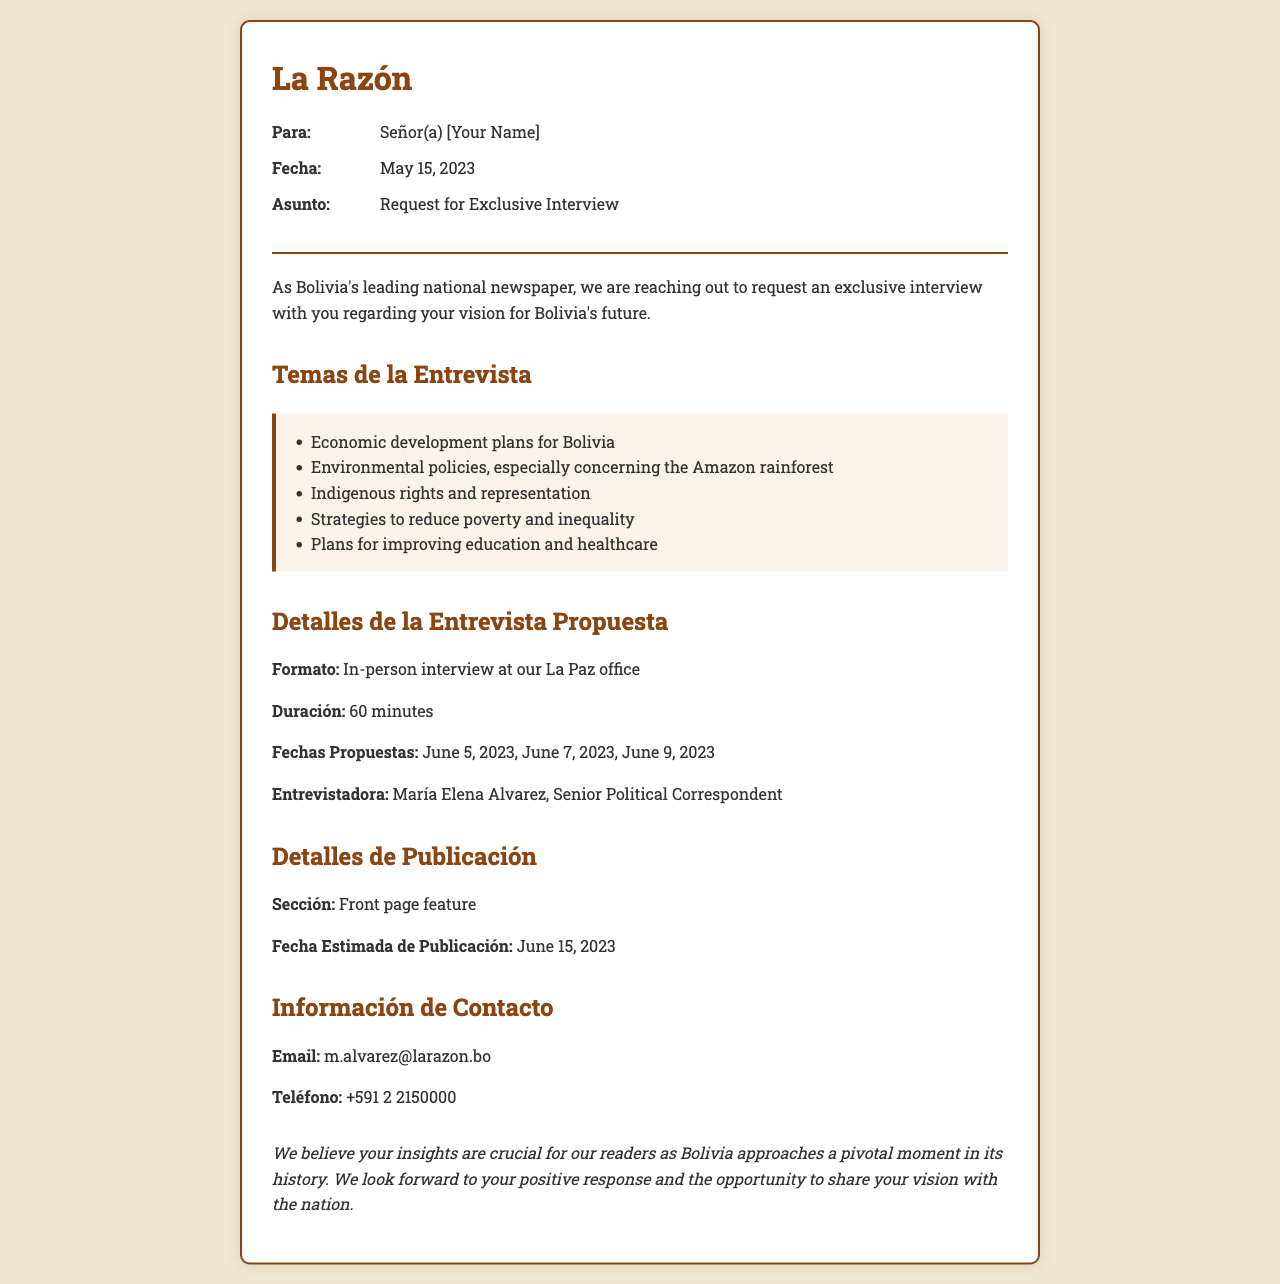what is the date of the fax? The date of the fax is indicated in the document, which is May 15, 2023.
Answer: May 15, 2023 who is the interviewer for the proposed interview? The document states that the interviewer is María Elena Alvarez, Senior Political Correspondent.
Answer: María Elena Alvarez what are the proposed interview dates? The proposed dates for the interview are listed in the document as June 5, 2023, June 7, 2023, and June 9, 2023.
Answer: June 5, 2023, June 7, 2023, June 9, 2023 what is the primary subject of the interview request? The primary subject of the interview request is indicated to be your vision for Bolivia's future.
Answer: Your vision for Bolivia's future how long is the proposed interview? The document specifies that the duration of the proposed interview is 60 minutes.
Answer: 60 minutes what section will the publication appear in? The section where the publication will appear is mentioned as the front page feature.
Answer: Front page feature what is the estimated publication date? The estimated date of publication is given in the document as June 15, 2023.
Answer: June 15, 2023 why do they want to interview you? They believe your insights are crucial for their readers as Bolivia approaches a pivotal moment in its history.
Answer: Your insights are crucial for our readers 